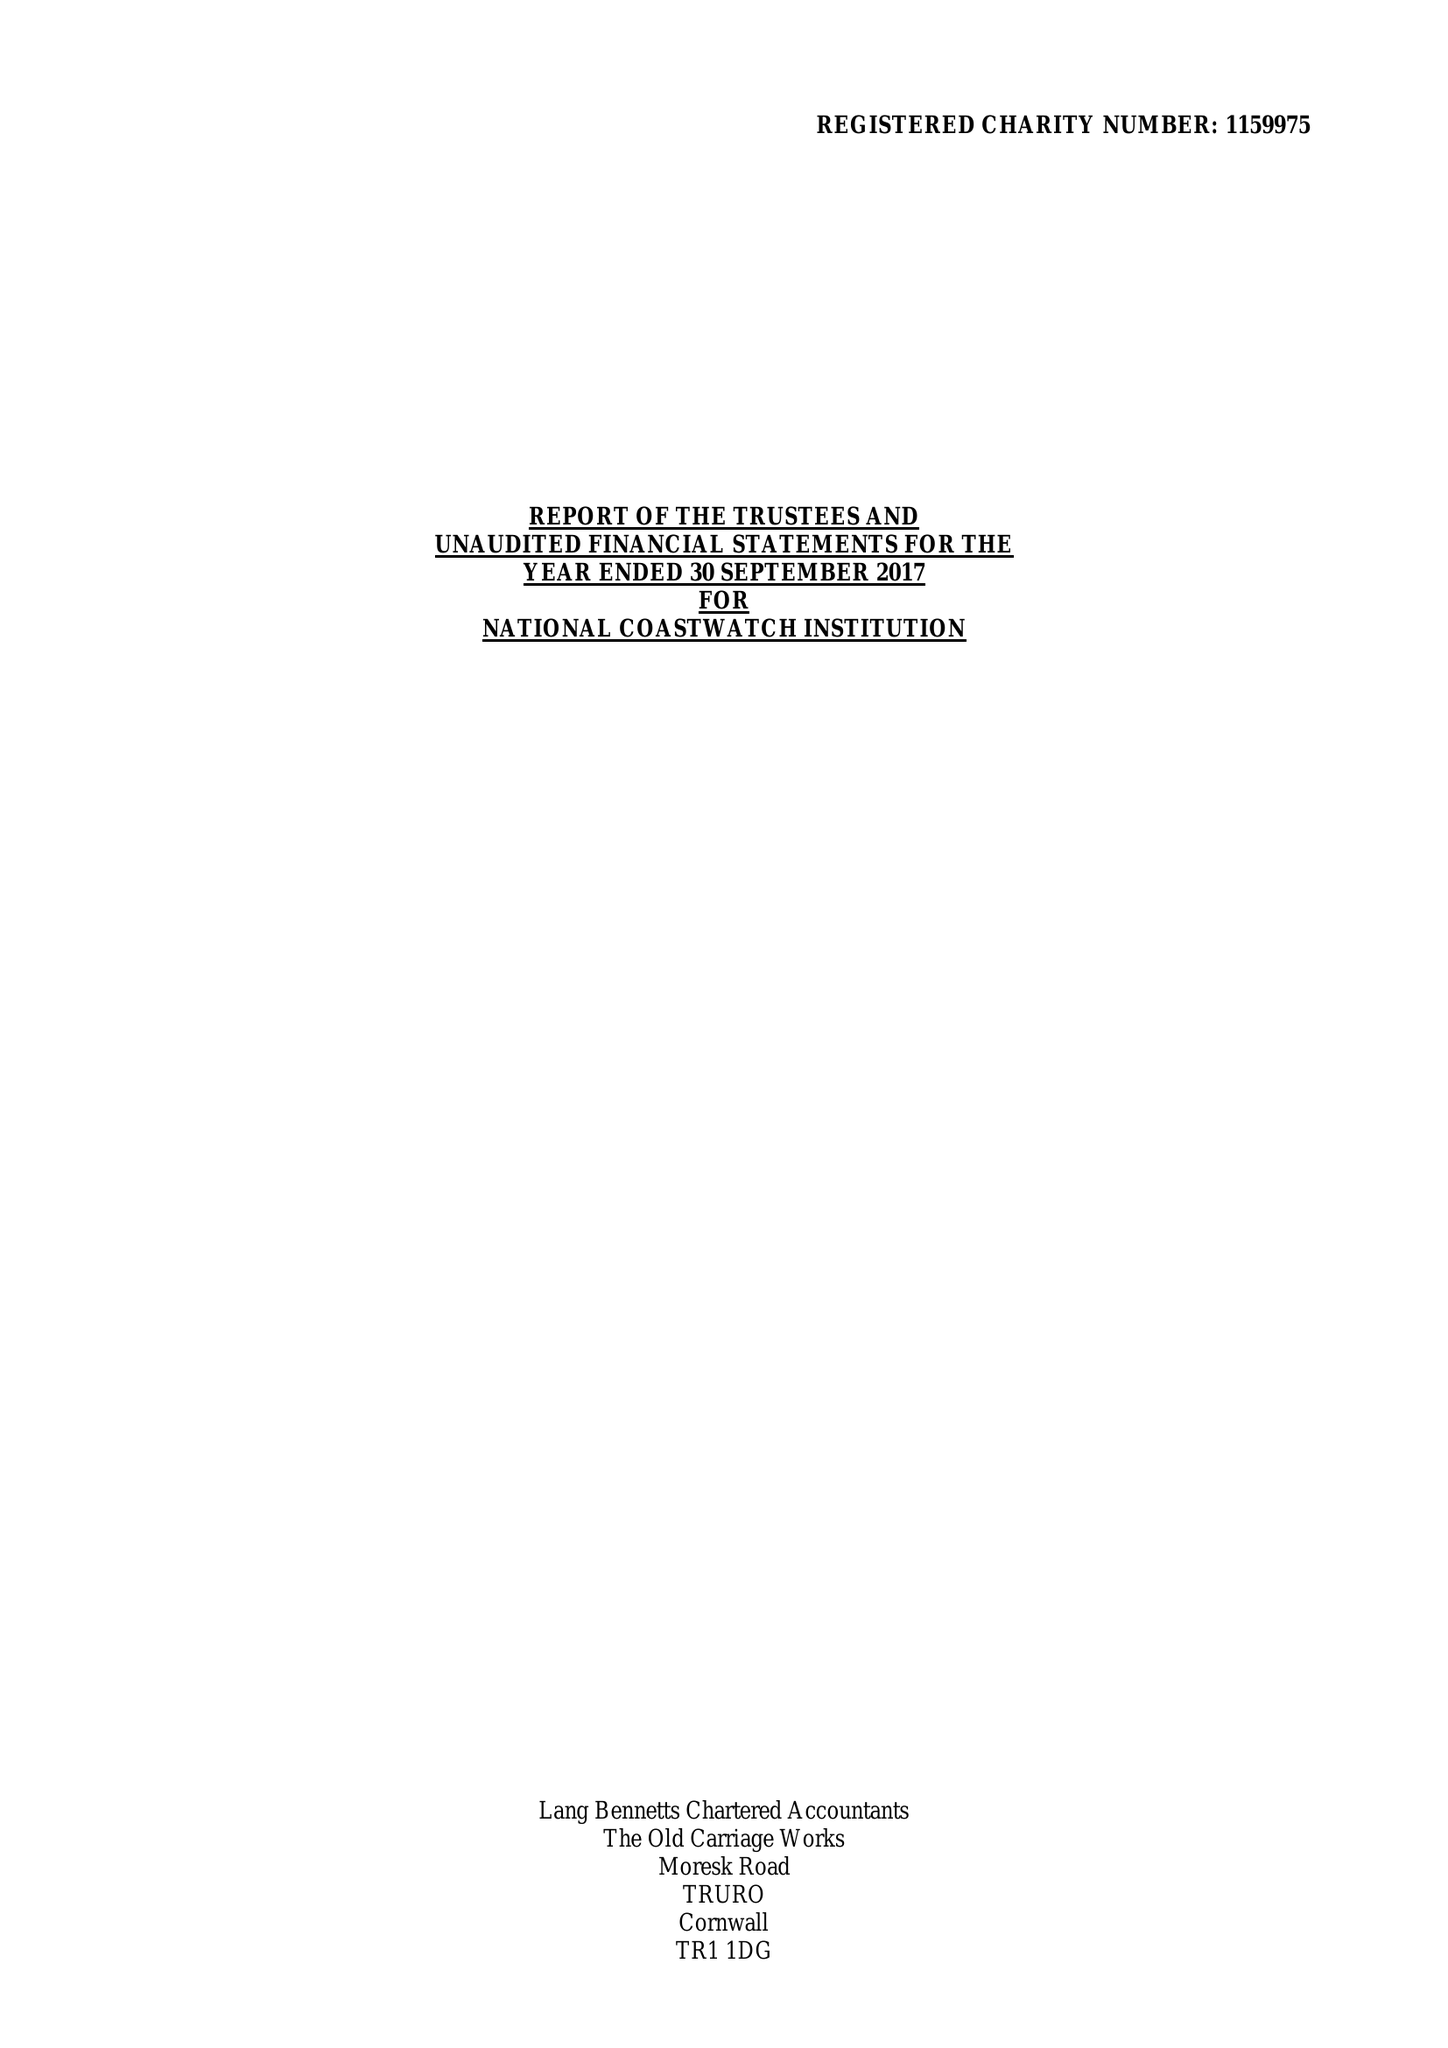What is the value for the charity_number?
Answer the question using a single word or phrase. 1159975 